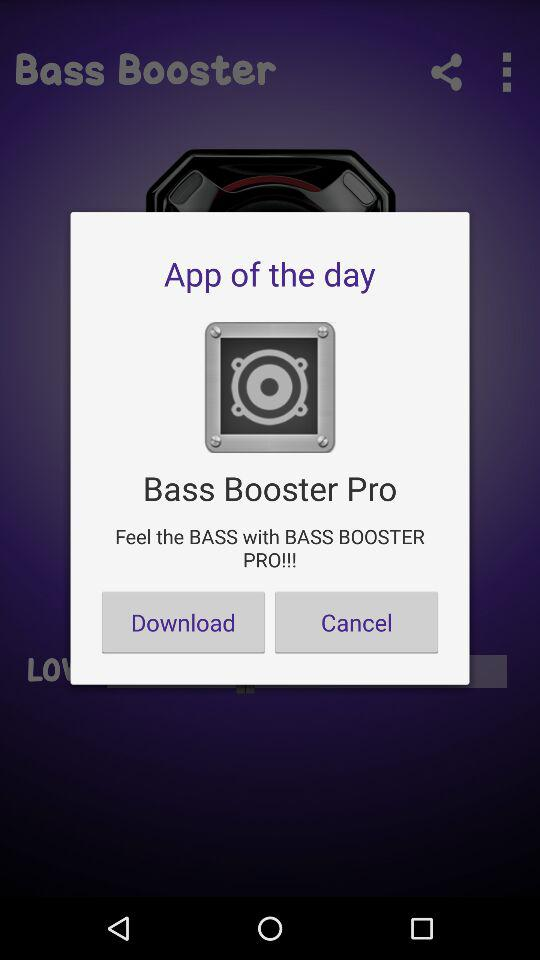What is the name of the application? The application name is "Bass Booster Pro". 